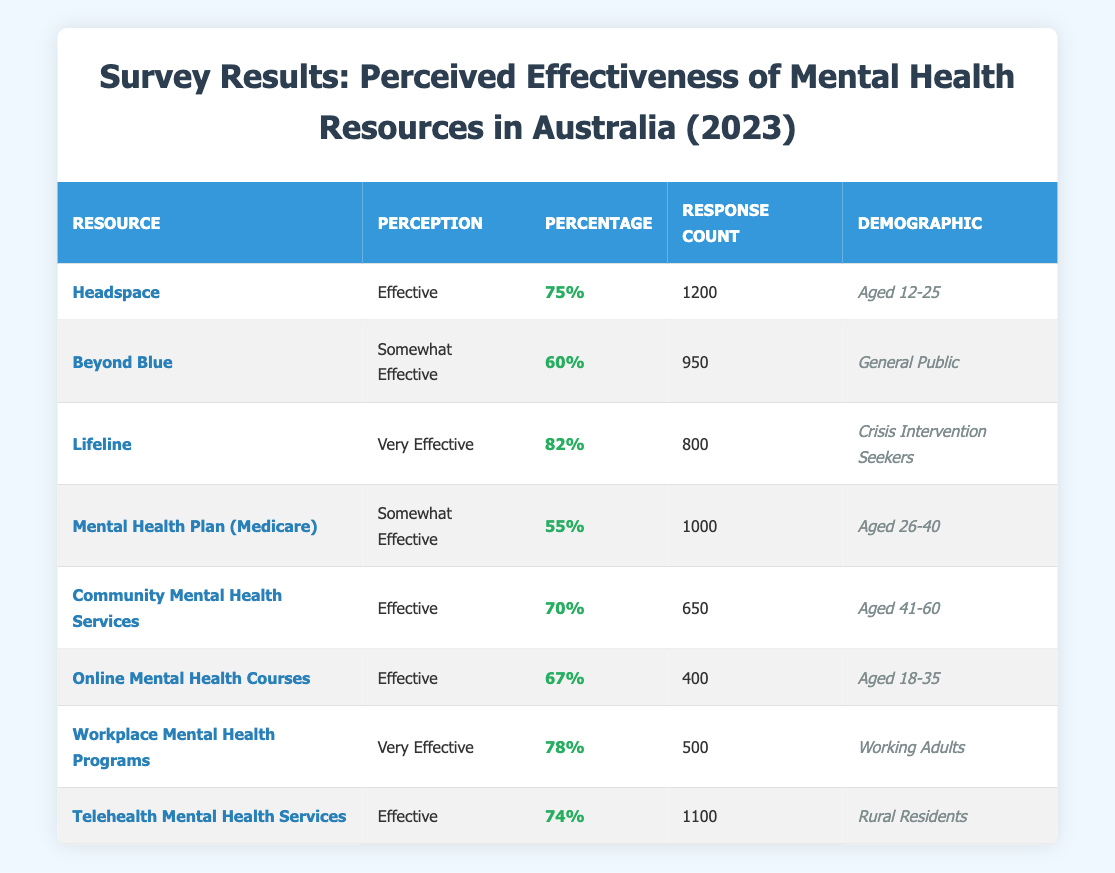What is the percentage of respondents who found Lifeline to be very effective? The table shows that Lifeline has a perception of "Very Effective" with a percentage of 82%.
Answer: 82% How many response counts were recorded for the Headspace resource? According to the table, Headspace received a response count of 1200.
Answer: 1200 Which resource had the highest perceived effectiveness percentage among crisis intervention seekers? The table indicates that Lifeline is rated as "Very Effective" by crisis intervention seekers, with a percentage of 82%, which is the highest for that demographic.
Answer: Lifeline Is the Mental Health Plan (Medicare) perceived as effective by more than 50% of respondents? The table shows that the perception of Mental Health Plan (Medicare) is "Somewhat Effective" with a percentage of 55%, which is greater than 50%.
Answer: Yes What is the average perceived effectiveness percentage of the resources provided for the demographic aged 12-25? For the demographic aged 12-25, only Headspace is listed with a percentage of 75%. Since there's only one percentage, the average is simply that value, 75%.
Answer: 75% Which resource had the lowest percentage of effectiveness perceived in the survey? Upon reviewing the table, the resource with the lowest perceived effectiveness percentage is the Mental Health Plan (Medicare) at 55%.
Answer: Mental Health Plan (Medicare) If you add the response counts from the resources rated as "Effective," what is the total? The resources rated as "Effective" are Headspace (1200), Community Mental Health Services (650), Online Mental Health Courses (400), and Telehealth Mental Health Services (1100). Adding these: 1200 + 650 + 400 + 1100 = 3350.
Answer: 3350 Is there a resource rated as "Somewhat Effective" that had at least 1000 total respondents? The table lists Mental Health Plan (Medicare) with a "Somewhat Effective" rating and a response count of 1000, thus it meets the criteria.
Answer: Yes What percentage of General Public respondents found Beyond Blue to be somewhat effective? The table specifies that Beyond Blue is perceived as "Somewhat Effective" by 60% of the General Public respondents.
Answer: 60% 